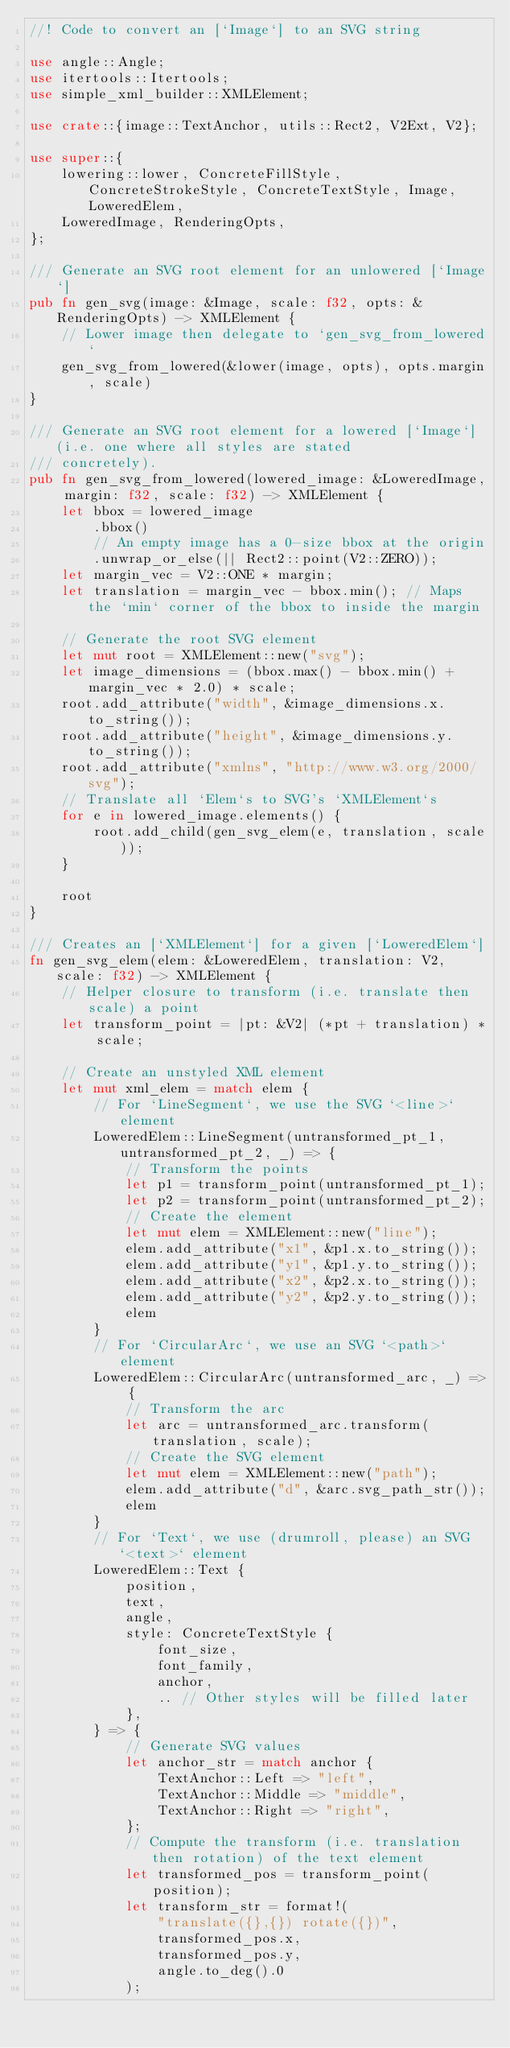<code> <loc_0><loc_0><loc_500><loc_500><_Rust_>//! Code to convert an [`Image`] to an SVG string

use angle::Angle;
use itertools::Itertools;
use simple_xml_builder::XMLElement;

use crate::{image::TextAnchor, utils::Rect2, V2Ext, V2};

use super::{
    lowering::lower, ConcreteFillStyle, ConcreteStrokeStyle, ConcreteTextStyle, Image, LoweredElem,
    LoweredImage, RenderingOpts,
};

/// Generate an SVG root element for an unlowered [`Image`]
pub fn gen_svg(image: &Image, scale: f32, opts: &RenderingOpts) -> XMLElement {
    // Lower image then delegate to `gen_svg_from_lowered`
    gen_svg_from_lowered(&lower(image, opts), opts.margin, scale)
}

/// Generate an SVG root element for a lowered [`Image`] (i.e. one where all styles are stated
/// concretely).
pub fn gen_svg_from_lowered(lowered_image: &LoweredImage, margin: f32, scale: f32) -> XMLElement {
    let bbox = lowered_image
        .bbox()
        // An empty image has a 0-size bbox at the origin
        .unwrap_or_else(|| Rect2::point(V2::ZERO));
    let margin_vec = V2::ONE * margin;
    let translation = margin_vec - bbox.min(); // Maps the `min` corner of the bbox to inside the margin

    // Generate the root SVG element
    let mut root = XMLElement::new("svg");
    let image_dimensions = (bbox.max() - bbox.min() + margin_vec * 2.0) * scale;
    root.add_attribute("width", &image_dimensions.x.to_string());
    root.add_attribute("height", &image_dimensions.y.to_string());
    root.add_attribute("xmlns", "http://www.w3.org/2000/svg");
    // Translate all `Elem`s to SVG's `XMLElement`s
    for e in lowered_image.elements() {
        root.add_child(gen_svg_elem(e, translation, scale));
    }

    root
}

/// Creates an [`XMLElement`] for a given [`LoweredElem`]
fn gen_svg_elem(elem: &LoweredElem, translation: V2, scale: f32) -> XMLElement {
    // Helper closure to transform (i.e. translate then scale) a point
    let transform_point = |pt: &V2| (*pt + translation) * scale;

    // Create an unstyled XML element
    let mut xml_elem = match elem {
        // For `LineSegment`, we use the SVG `<line>` element
        LoweredElem::LineSegment(untransformed_pt_1, untransformed_pt_2, _) => {
            // Transform the points
            let p1 = transform_point(untransformed_pt_1);
            let p2 = transform_point(untransformed_pt_2);
            // Create the element
            let mut elem = XMLElement::new("line");
            elem.add_attribute("x1", &p1.x.to_string());
            elem.add_attribute("y1", &p1.y.to_string());
            elem.add_attribute("x2", &p2.x.to_string());
            elem.add_attribute("y2", &p2.y.to_string());
            elem
        }
        // For `CircularArc`, we use an SVG `<path>` element
        LoweredElem::CircularArc(untransformed_arc, _) => {
            // Transform the arc
            let arc = untransformed_arc.transform(translation, scale);
            // Create the SVG element
            let mut elem = XMLElement::new("path");
            elem.add_attribute("d", &arc.svg_path_str());
            elem
        }
        // For `Text`, we use (drumroll, please) an SVG `<text>` element
        LoweredElem::Text {
            position,
            text,
            angle,
            style: ConcreteTextStyle {
                font_size,
                font_family,
                anchor,
                .. // Other styles will be filled later
            },
        } => {
            // Generate SVG values
            let anchor_str = match anchor {
                TextAnchor::Left => "left",
                TextAnchor::Middle => "middle",
                TextAnchor::Right => "right",
            };
            // Compute the transform (i.e. translation then rotation) of the text element
            let transformed_pos = transform_point(position);
            let transform_str = format!(
                "translate({},{}) rotate({})",
                transformed_pos.x,
                transformed_pos.y,
                angle.to_deg().0
            );</code> 